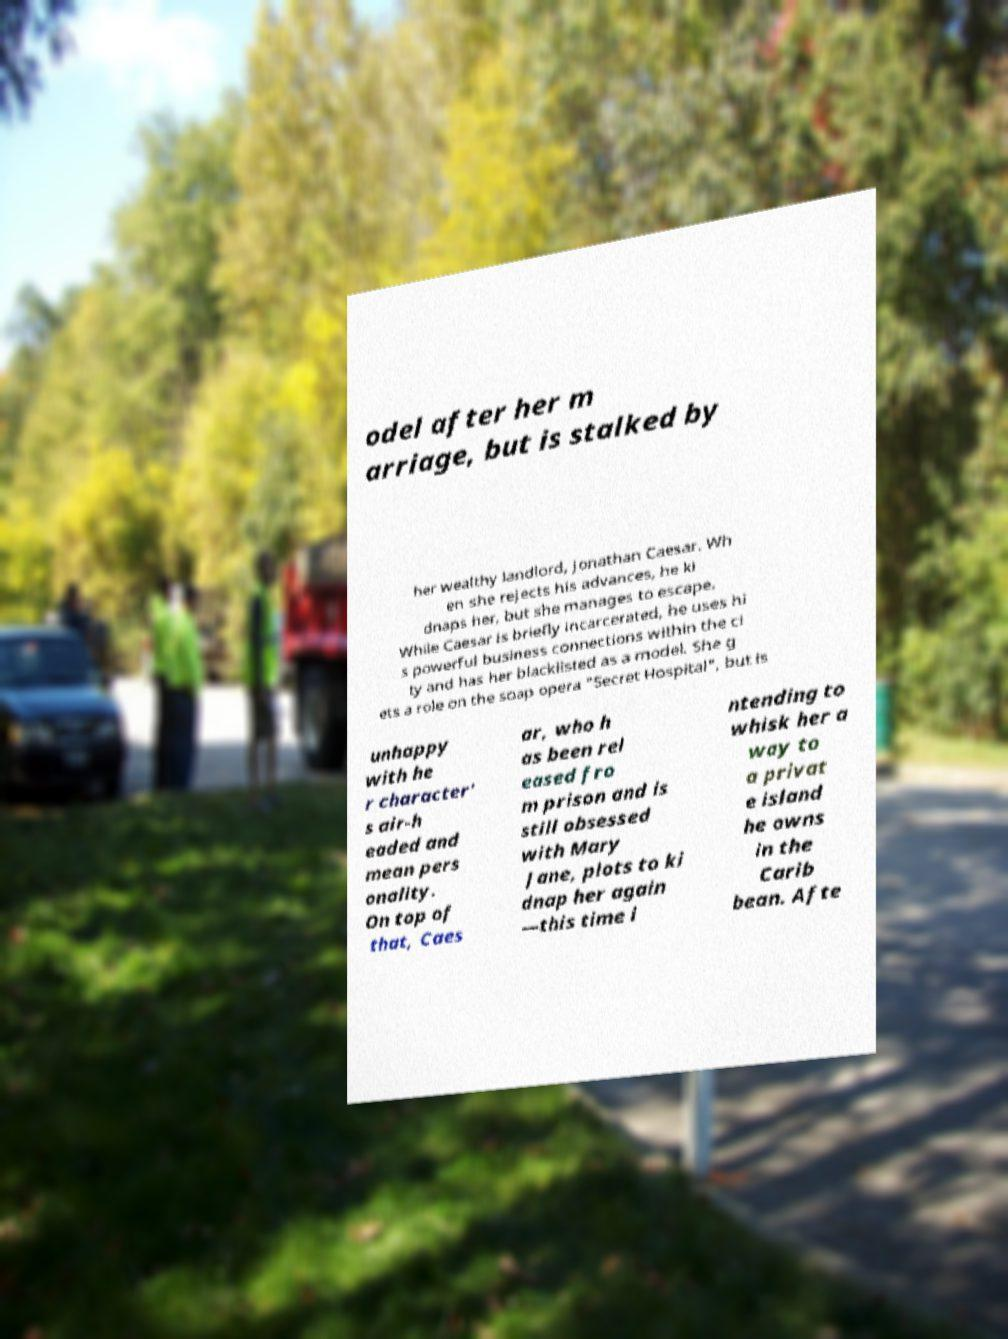Please identify and transcribe the text found in this image. odel after her m arriage, but is stalked by her wealthy landlord, Jonathan Caesar. Wh en she rejects his advances, he ki dnaps her, but she manages to escape. While Caesar is briefly incarcerated, he uses hi s powerful business connections within the ci ty and has her blacklisted as a model. She g ets a role on the soap opera "Secret Hospital", but is unhappy with he r character' s air-h eaded and mean pers onality. On top of that, Caes ar, who h as been rel eased fro m prison and is still obsessed with Mary Jane, plots to ki dnap her again —this time i ntending to whisk her a way to a privat e island he owns in the Carib bean. Afte 